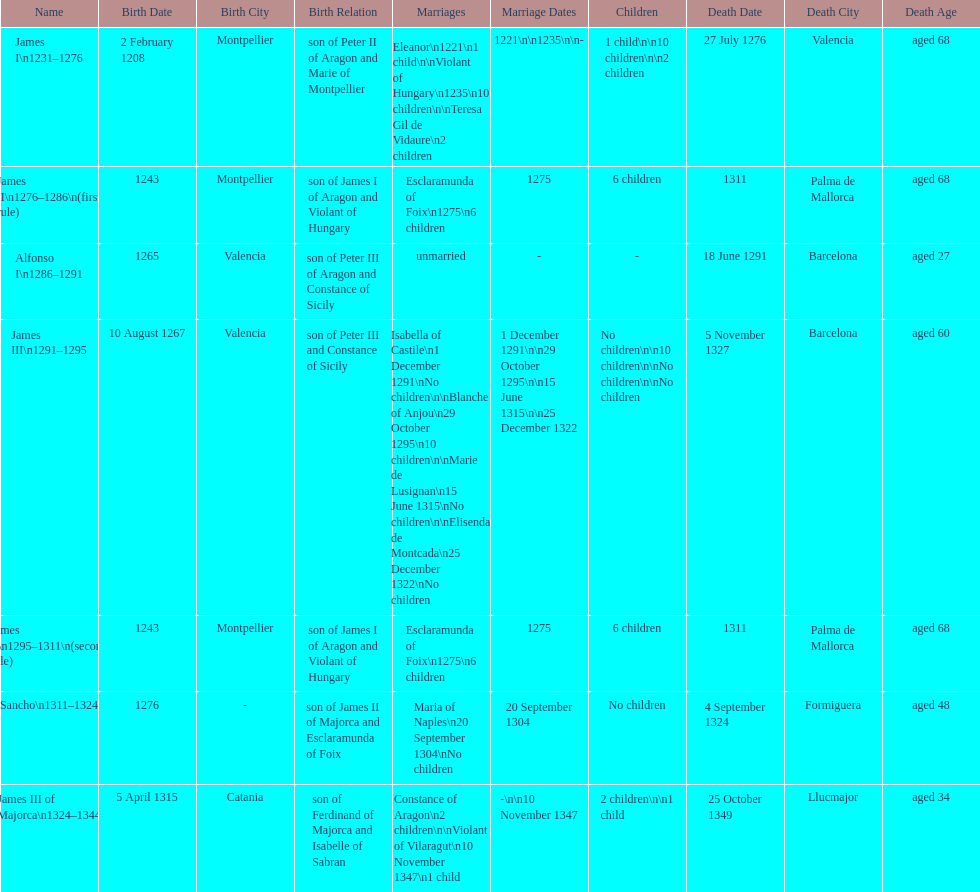Who came to power after the rule of james iii? James II. Would you be able to parse every entry in this table? {'header': ['Name', 'Birth Date', 'Birth City', 'Birth Relation', 'Marriages', 'Marriage Dates', 'Children', 'Death Date', 'Death City', 'Death Age'], 'rows': [['James I\\n1231–1276', '2 February 1208', 'Montpellier', 'son of Peter II of Aragon and Marie of Montpellier', 'Eleanor\\n1221\\n1 child\\n\\nViolant of Hungary\\n1235\\n10 children\\n\\nTeresa Gil de Vidaure\\n2 children', '1221\\n\\n1235\\n\\n-', '1 child\\n\\n10 children\\n\\n2 children', '27 July 1276', 'Valencia', 'aged 68'], ['James II\\n1276–1286\\n(first rule)', '1243', 'Montpellier', 'son of James I of Aragon and Violant of Hungary', 'Esclaramunda of Foix\\n1275\\n6 children', '1275', '6 children', '1311', 'Palma de Mallorca', 'aged 68'], ['Alfonso I\\n1286–1291', '1265', 'Valencia', 'son of Peter III of Aragon and Constance of Sicily', 'unmarried', '-', '-', '18 June 1291', 'Barcelona', 'aged 27'], ['James III\\n1291–1295', '10 August 1267', 'Valencia', 'son of Peter III and Constance of Sicily', 'Isabella of Castile\\n1 December 1291\\nNo children\\n\\nBlanche of Anjou\\n29 October 1295\\n10 children\\n\\nMarie de Lusignan\\n15 June 1315\\nNo children\\n\\nElisenda de Montcada\\n25 December 1322\\nNo children', '1 December 1291\\n\\n29 October 1295\\n\\n15 June 1315\\n\\n25 December 1322', 'No children\\n\\n10 children\\n\\nNo children\\n\\nNo children', '5 November 1327', 'Barcelona', 'aged 60'], ['James II\\n1295–1311\\n(second rule)', '1243', 'Montpellier', 'son of James I of Aragon and Violant of Hungary', 'Esclaramunda of Foix\\n1275\\n6 children', '1275', '6 children', '1311', 'Palma de Mallorca', 'aged 68'], ['Sancho\\n1311–1324', '1276', '-', 'son of James II of Majorca and Esclaramunda of Foix', 'Maria of Naples\\n20 September 1304\\nNo children', '20 September 1304', 'No children', '4 September 1324', 'Formiguera', 'aged 48'], ['James III of Majorca\\n1324–1344', '5 April 1315', 'Catania', 'son of Ferdinand of Majorca and Isabelle of Sabran', 'Constance of Aragon\\n2 children\\n\\nViolant of Vilaragut\\n10 November 1347\\n1 child', '-\\n\\n10 November 1347', '2 children\\n\\n1 child', '25 October 1349', 'Llucmajor', 'aged 34']]} 